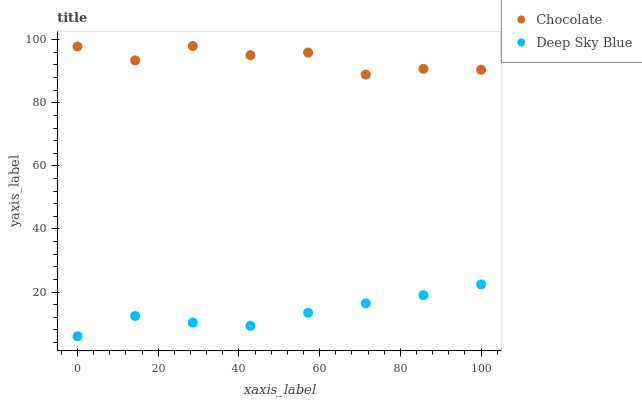Does Deep Sky Blue have the minimum area under the curve?
Answer yes or no. Yes. Does Chocolate have the maximum area under the curve?
Answer yes or no. Yes. Does Chocolate have the minimum area under the curve?
Answer yes or no. No. Is Deep Sky Blue the smoothest?
Answer yes or no. Yes. Is Chocolate the roughest?
Answer yes or no. Yes. Is Chocolate the smoothest?
Answer yes or no. No. Does Deep Sky Blue have the lowest value?
Answer yes or no. Yes. Does Chocolate have the lowest value?
Answer yes or no. No. Does Chocolate have the highest value?
Answer yes or no. Yes. Is Deep Sky Blue less than Chocolate?
Answer yes or no. Yes. Is Chocolate greater than Deep Sky Blue?
Answer yes or no. Yes. Does Deep Sky Blue intersect Chocolate?
Answer yes or no. No. 